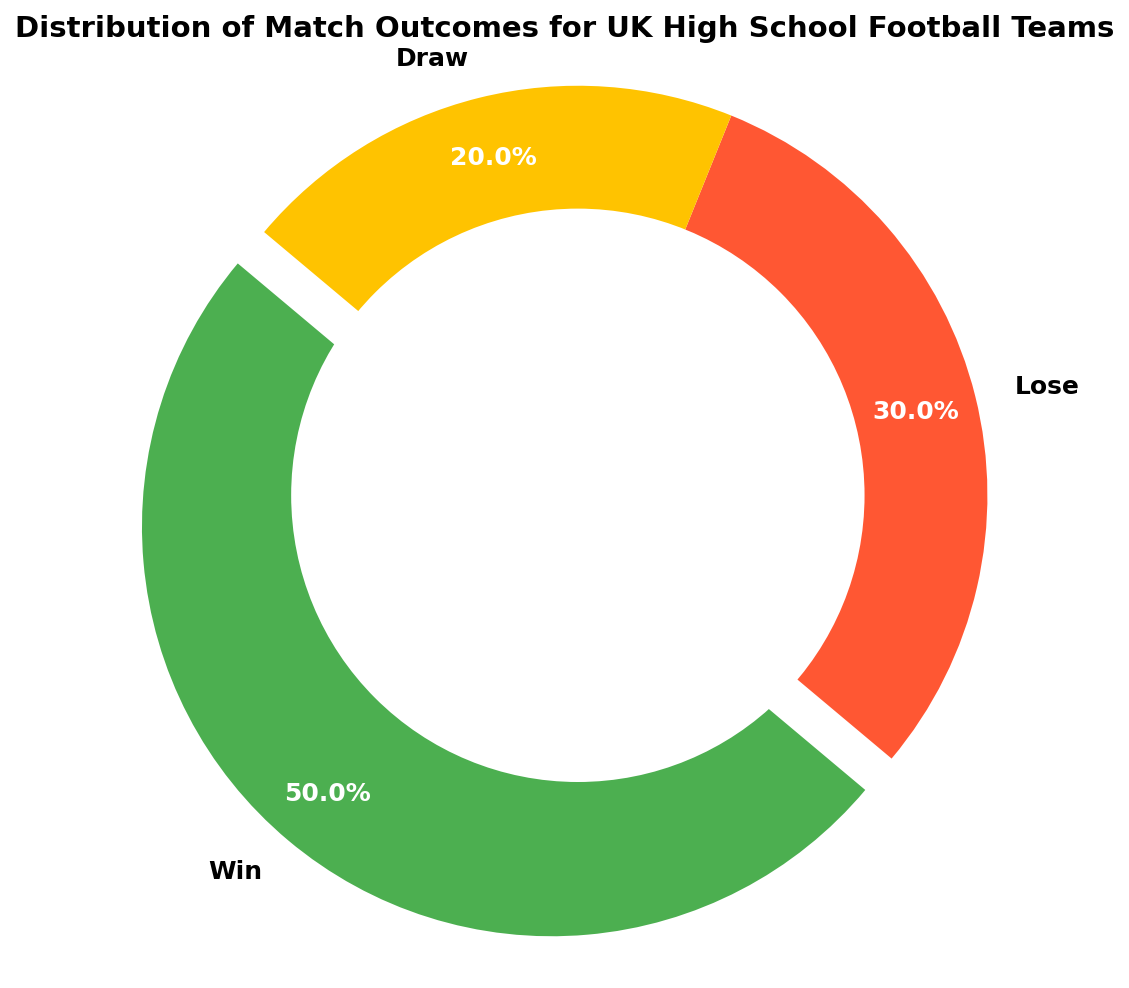What percentage of matches ended in a win? The green section of the ring chart represents wins. The percentage on the chart for the win section is 50.0%.
Answer: 50.0% Which outcome has the smallest percentage of matches? The yellow section of the ring chart represents draws, and it is the smallest section on the chart. The percentage on the chart for the draw section is 20.0%.
Answer: Draw How many total matches were played? To find the total number of matches, sum the counts of all outcomes: 50 (wins) + 30 (losses) + 20 (draws) = 100.
Answer: 100 What is the ratio of wins to losses? The count for wins is 50, and the count for losses is 30. The ratio is calculated as 50/30 which simplifies to approximately 1.67.
Answer: 1.67 How does the number of draws compare to the number of losses? The count for draws is 20, and the count for losses is 30. Since 20 is less than 30, draws are fewer than losses.
Answer: Less If you were to combine the counts of losses and draws, what percentage of the total matches would these represent? Combine the losses and draws: 30 (losses) + 20 (draws) = 50. Calculate the percentage: (50/100) * 100% = 50.0%.
Answer: 50.0% What color represents the outcome with the highest count? The green section of the ring chart represents the outcome with the highest count, which is wins.
Answer: Green What is the difference in the number of wins and draws? The count for wins is 50, and the count for draws is 20. The difference is calculated as 50 - 20 = 30.
Answer: 30 What percentage of matches did not result in a win? Combine the losses and draws: 30 (losses) + 20 (draws) = 50. Calculate the percentage: (50/100) * 100% = 50.0%.
Answer: 50.0% Is the percentage of wins closer to the percentage of losses or draws? The percentage of wins is 50.0%. Losses account for 30.0%, and draws account for 20.0%. The percentage of wins is closer to losses than draws because the difference between wins and losses is 20%, whereas the difference between wins and draws is 30%.
Answer: Losses 